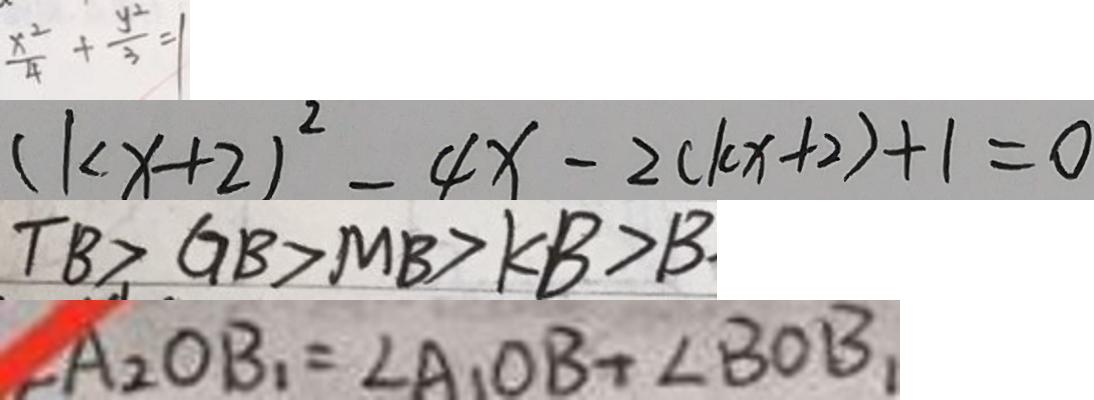<formula> <loc_0><loc_0><loc_500><loc_500>\frac { x ^ { 2 } } { 4 } + \frac { y ^ { 2 } } { 3 } = 1 
 ( k x + 2 ) ^ { 2 } - 4 x - 2 ( k x + 2 ) + 1 = 0 
 T B > G B > M B > K B > B 
 \angle A _ { 2 } O B _ { 1 } = \angle A _ { 1 } O B + \angle B O B _ { 1 }</formula> 